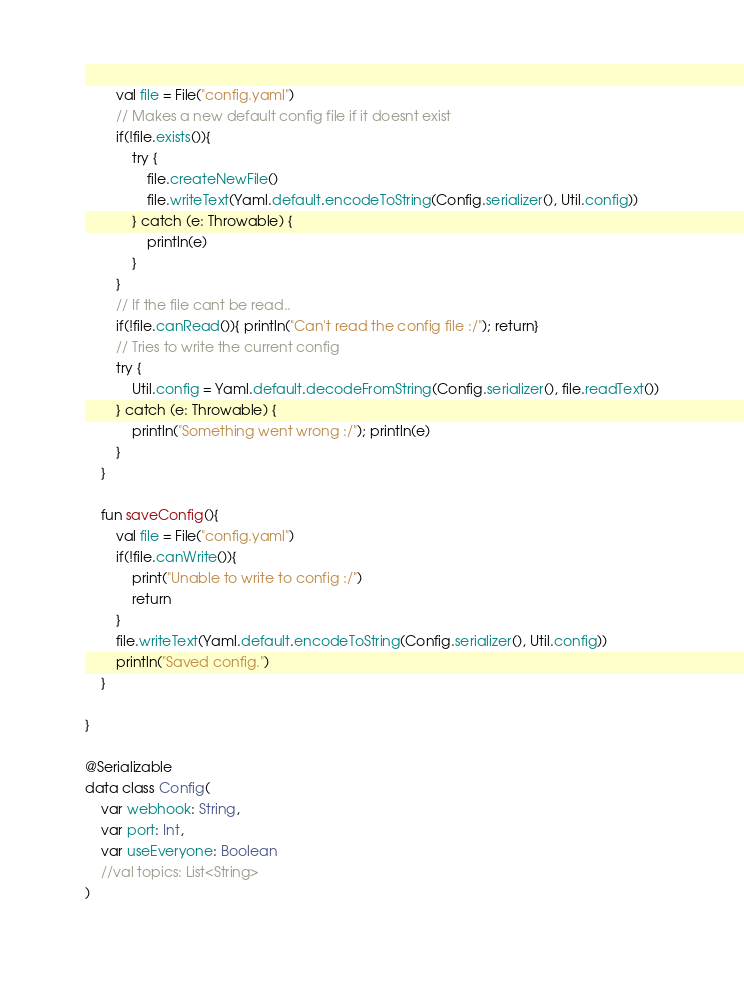<code> <loc_0><loc_0><loc_500><loc_500><_Kotlin_>        val file = File("config.yaml")
        // Makes a new default config file if it doesnt exist
        if(!file.exists()){
            try {
                file.createNewFile()
                file.writeText(Yaml.default.encodeToString(Config.serializer(), Util.config))
            } catch (e: Throwable) {
                println(e)
            }
        }
        // If the file cant be read..
        if(!file.canRead()){ println("Can't read the config file :/"); return}
        // Tries to write the current config
        try {
            Util.config = Yaml.default.decodeFromString(Config.serializer(), file.readText())
        } catch (e: Throwable) {
            println("Something went wrong :/"); println(e)
        }
    }

    fun saveConfig(){
        val file = File("config.yaml")
        if(!file.canWrite()){
            print("Unable to write to config :/")
            return
        }
        file.writeText(Yaml.default.encodeToString(Config.serializer(), Util.config))
        println("Saved config.")
    }

}

@Serializable
data class Config(
    var webhook: String,
    var port: Int,
    var useEveryone: Boolean
    //val topics: List<String>
)
</code> 